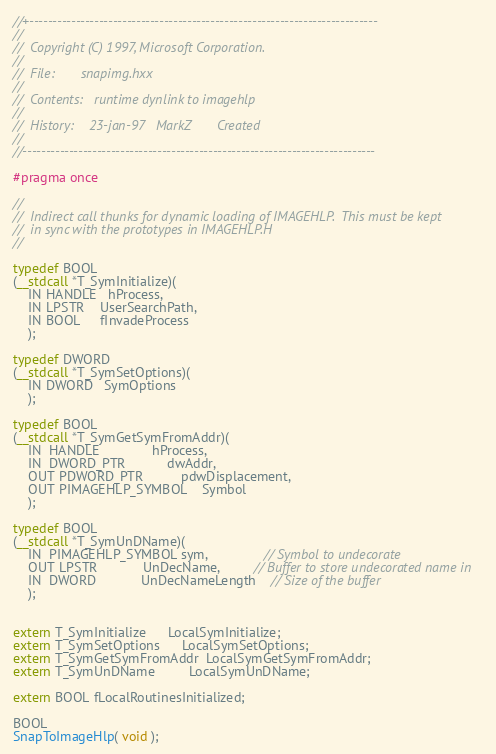<code> <loc_0><loc_0><loc_500><loc_500><_C++_>//+---------------------------------------------------------------------------
//
//  Copyright (C) 1997, Microsoft Corporation.
//
//  File:       snapimg.hxx
//
//  Contents:   runtime dynlink to imagehlp
//
//  History:    23-jan-97   MarkZ       Created
//
//----------------------------------------------------------------------------

#pragma once

//
//  Indirect call thunks for dynamic loading of IMAGEHLP.  This must be kept
//  in sync with the prototypes in IMAGEHLP.H
//

typedef BOOL
(__stdcall *T_SymInitialize)(
    IN HANDLE   hProcess,
    IN LPSTR    UserSearchPath,
    IN BOOL     fInvadeProcess
    );

typedef DWORD
(__stdcall *T_SymSetOptions)(
    IN DWORD   SymOptions
    );

typedef BOOL
(__stdcall *T_SymGetSymFromAddr)(
    IN  HANDLE              hProcess,
    IN  DWORD_PTR           dwAddr,
    OUT PDWORD_PTR          pdwDisplacement,
    OUT PIMAGEHLP_SYMBOL    Symbol
    );

typedef BOOL
(__stdcall *T_SymUnDName)(
    IN  PIMAGEHLP_SYMBOL sym,               // Symbol to undecorate
    OUT LPSTR            UnDecName,         // Buffer to store undecorated name in
    IN  DWORD            UnDecNameLength    // Size of the buffer
    );


extern T_SymInitialize      LocalSymInitialize;
extern T_SymSetOptions      LocalSymSetOptions;
extern T_SymGetSymFromAddr  LocalSymGetSymFromAddr;
extern T_SymUnDName         LocalSymUnDName;

extern BOOL fLocalRoutinesInitialized;

BOOL
SnapToImageHlp( void );

</code> 